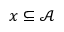Convert formula to latex. <formula><loc_0><loc_0><loc_500><loc_500>x \subseteq { \mathcal { A } }</formula> 